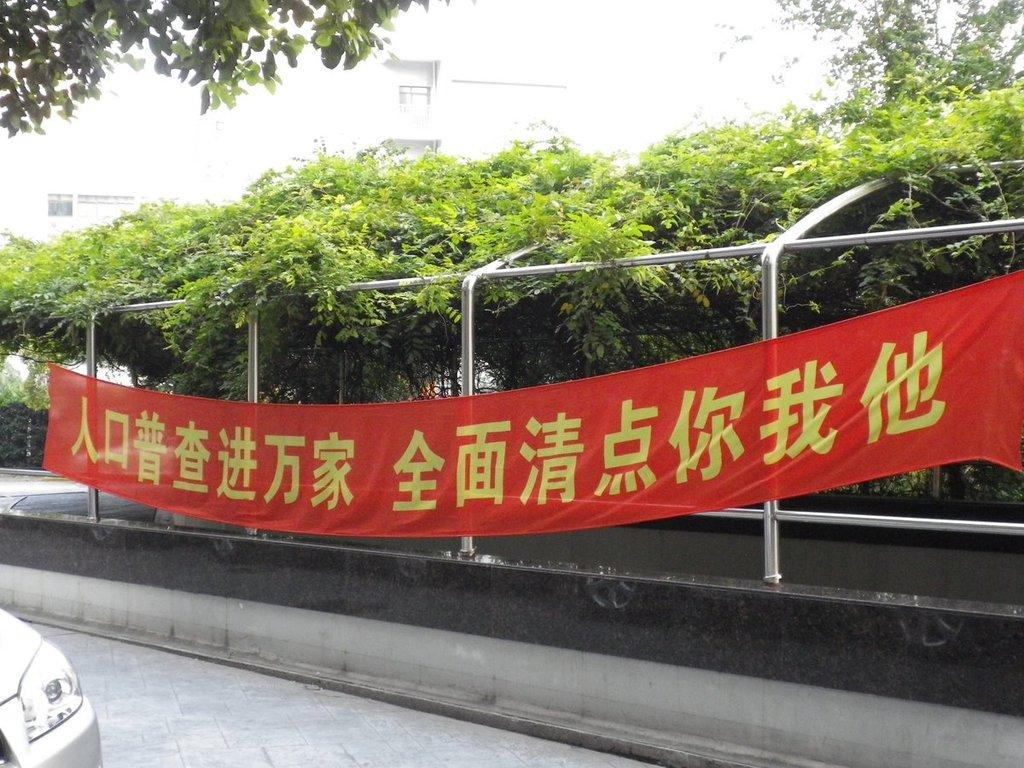What is the main subject of the image? There is a car on a road in the image. What can be seen beside the road? There is fencing beside the road. What is attached to the fencing? There is a banner attached to the fencing. What is written on the banner? The banner has some text on it. What is visible in the background of the image? There are trees visible in the background of the image. What type of sail is attached to the car in the image? There is no sail attached to the car in the image; it is a regular car on a road. What title does the banner have in the image? The banner in the image does not have a title, as it is not a book or document. 